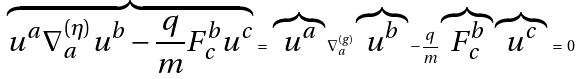Convert formula to latex. <formula><loc_0><loc_0><loc_500><loc_500>\overbrace { u ^ { a } \nabla ^ { ( \eta ) } _ { a } u ^ { b } - \frac { q } { m } F ^ { b } _ { c } u ^ { c } } \, = \, \overbrace { u ^ { a } } \nabla ^ { ( g ) } _ { a } \overbrace { u ^ { b } } - \frac { q } { m } \overbrace { F ^ { b } _ { c } } \overbrace { u ^ { c } } \, = \, 0</formula> 